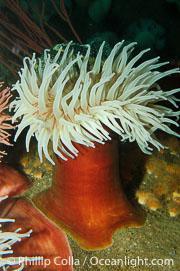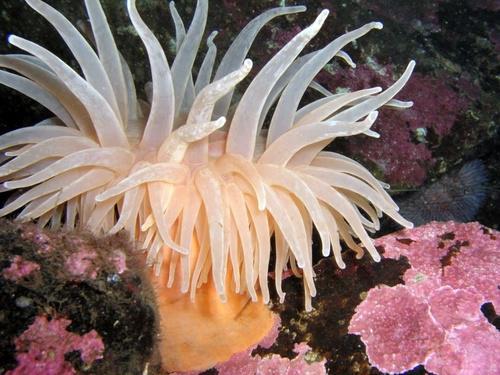The first image is the image on the left, the second image is the image on the right. For the images shown, is this caption "An image includes an anemone with rich orange-red tendrils." true? Answer yes or no. No. The first image is the image on the left, the second image is the image on the right. For the images displayed, is the sentence "there are two anemones in one of the images" factually correct? Answer yes or no. No. 